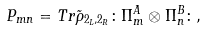<formula> <loc_0><loc_0><loc_500><loc_500>P _ { m n } = T r \tilde { \rho } _ { 2 _ { L } , 2 _ { R } } \colon \Pi ^ { A } _ { m } \otimes \Pi ^ { B } _ { n } \colon ,</formula> 